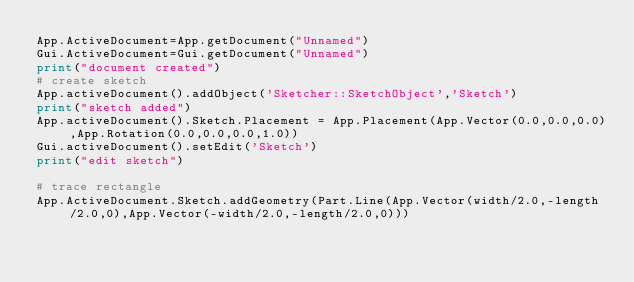Convert code to text. <code><loc_0><loc_0><loc_500><loc_500><_Python_>App.ActiveDocument=App.getDocument("Unnamed")
Gui.ActiveDocument=Gui.getDocument("Unnamed")
print("document created")
# create sketch
App.activeDocument().addObject('Sketcher::SketchObject','Sketch')
print("sketch added")
App.activeDocument().Sketch.Placement = App.Placement(App.Vector(0.0,0.0,0.0),App.Rotation(0.0,0.0,0.0,1.0))
Gui.activeDocument().setEdit('Sketch')
print("edit sketch")

# trace rectangle
App.ActiveDocument.Sketch.addGeometry(Part.Line(App.Vector(width/2.0,-length/2.0,0),App.Vector(-width/2.0,-length/2.0,0)))</code> 